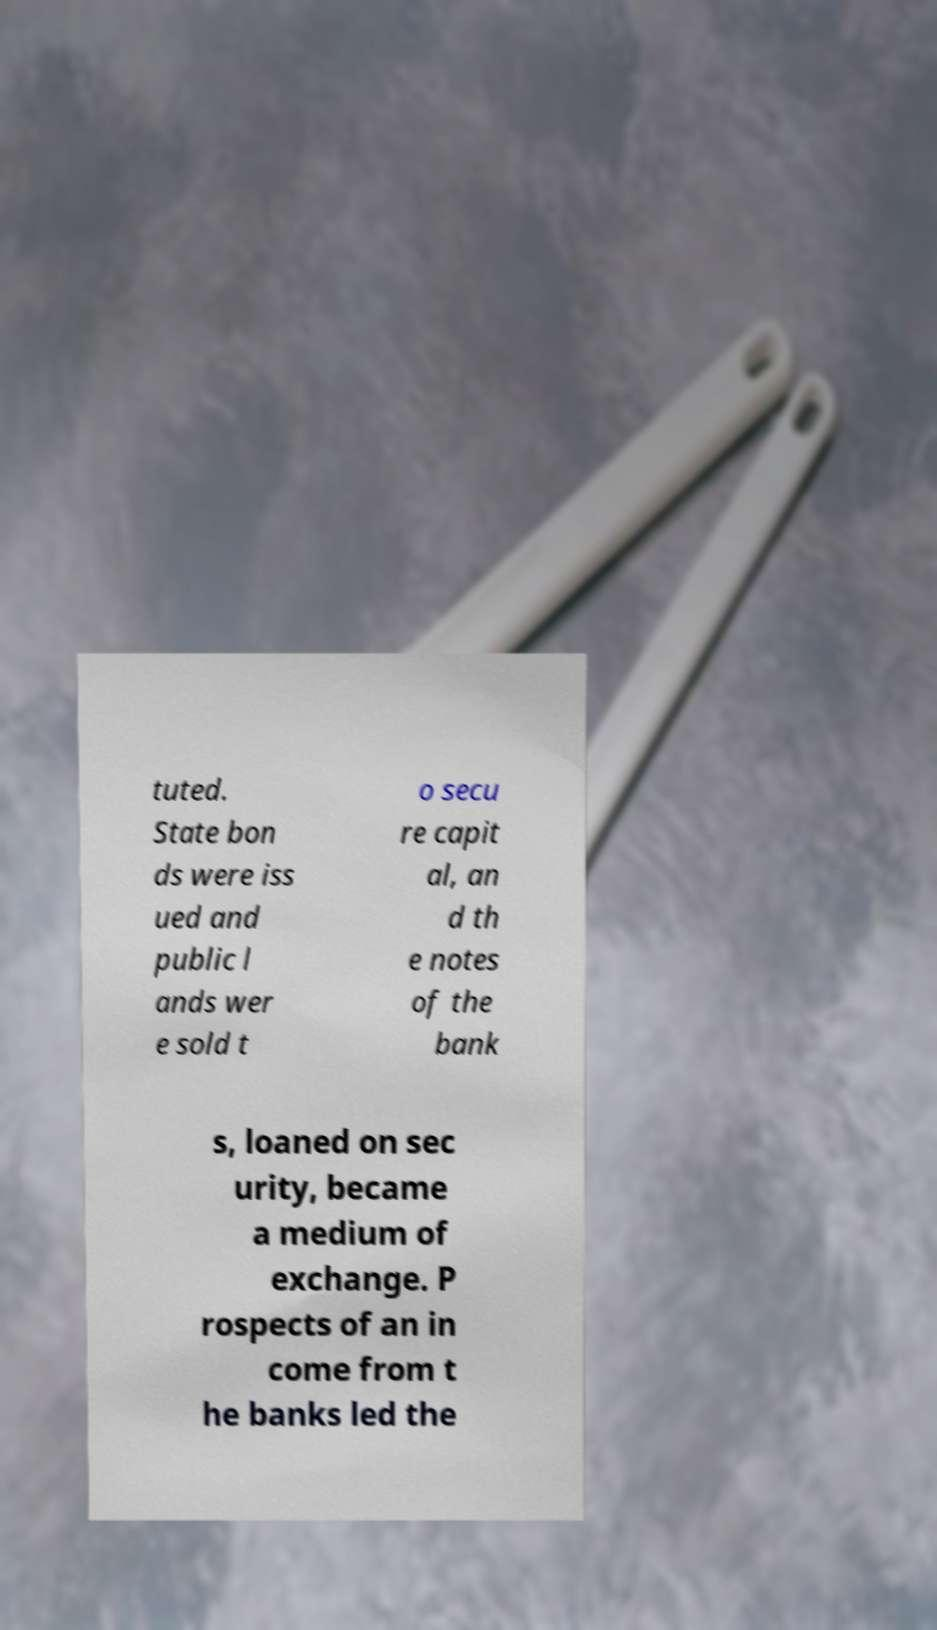Can you accurately transcribe the text from the provided image for me? tuted. State bon ds were iss ued and public l ands wer e sold t o secu re capit al, an d th e notes of the bank s, loaned on sec urity, became a medium of exchange. P rospects of an in come from t he banks led the 